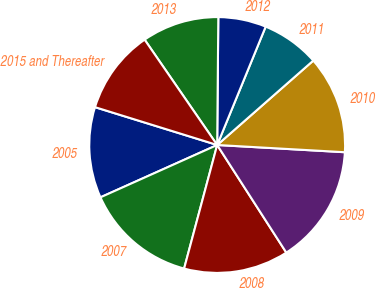<chart> <loc_0><loc_0><loc_500><loc_500><pie_chart><fcel>2005<fcel>2007<fcel>2008<fcel>2009<fcel>2010<fcel>2011<fcel>2012<fcel>2013<fcel>2015 and Thereafter<nl><fcel>11.49%<fcel>14.13%<fcel>13.25%<fcel>15.01%<fcel>12.37%<fcel>7.34%<fcel>6.05%<fcel>9.74%<fcel>10.62%<nl></chart> 